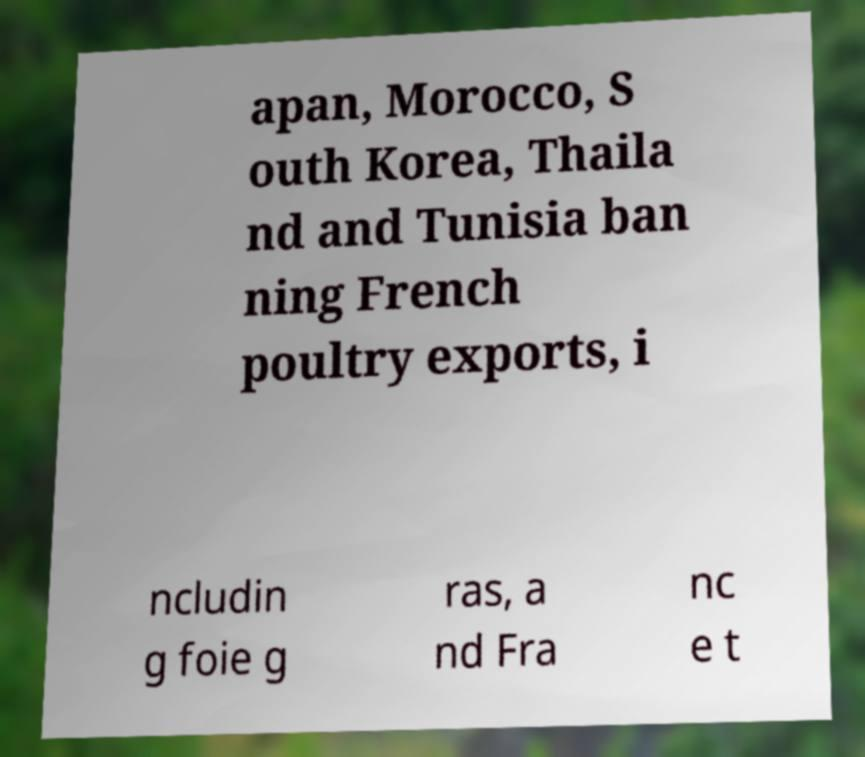For documentation purposes, I need the text within this image transcribed. Could you provide that? apan, Morocco, S outh Korea, Thaila nd and Tunisia ban ning French poultry exports, i ncludin g foie g ras, a nd Fra nc e t 